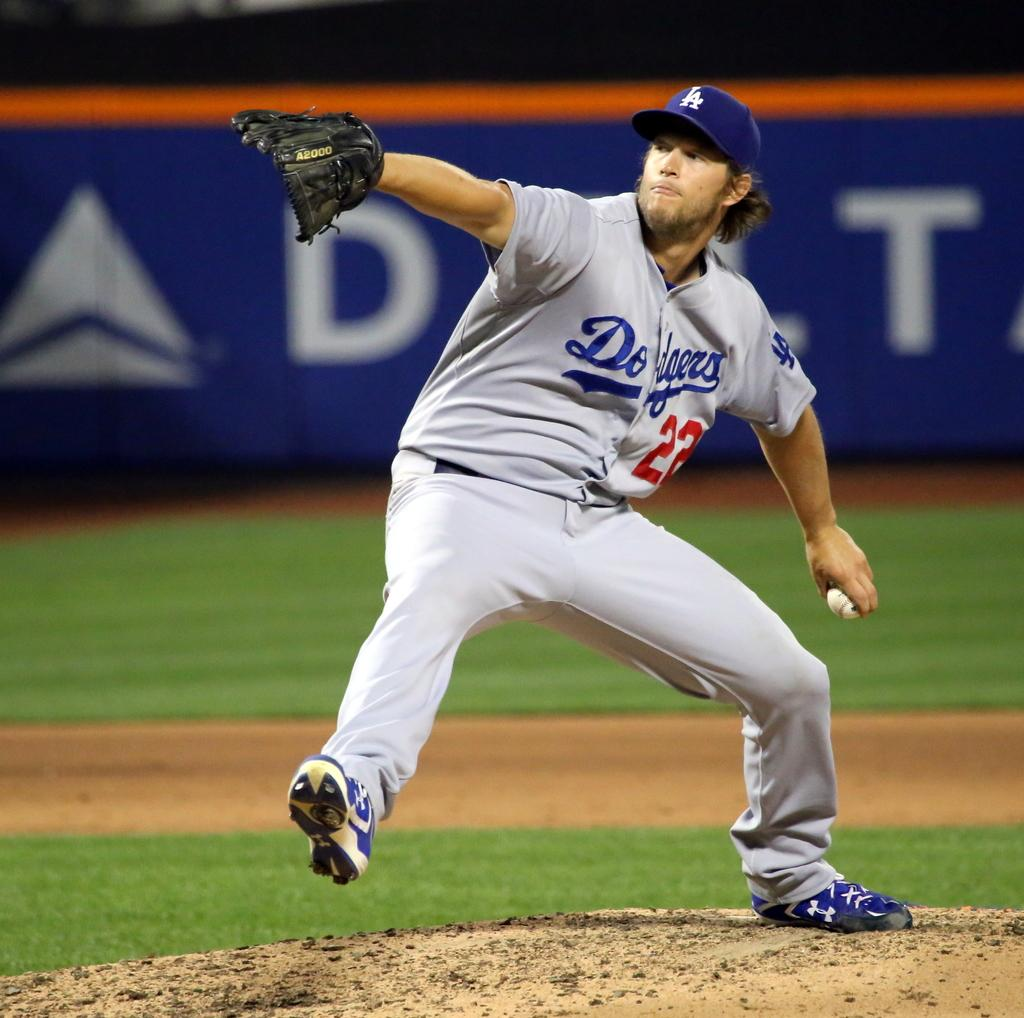<image>
Write a terse but informative summary of the picture. baseball player 22 for the dodgers about to throw a ball 